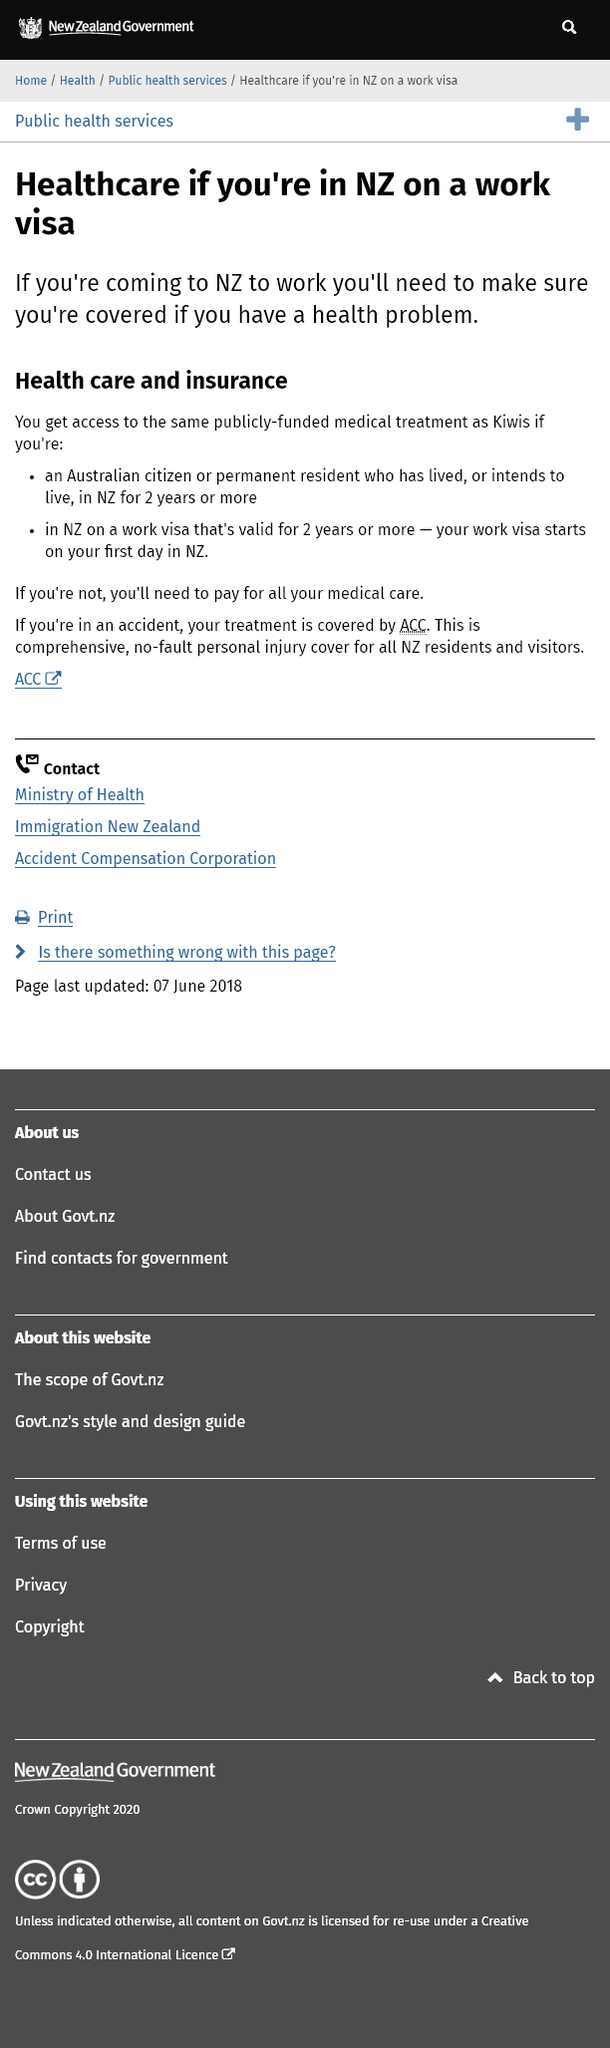Draw attention to some important aspects in this diagram. If you are in an accident, your treatment will be covered by ACC. In general, you will be responsible for paying for your medical care in New Zealand unless you are involved in an accident, are an Australian citizen or permanent resident who has lived in New Zealand for 2 years or more, or have a valid work visa that is valid for 2 years or more. ACC, or Accident Compensation Corporation, is a comprehensive and no-fault insurance program that provides coverage for all New Zealand residents and visitors who have experienced injury as a result of an accident. 